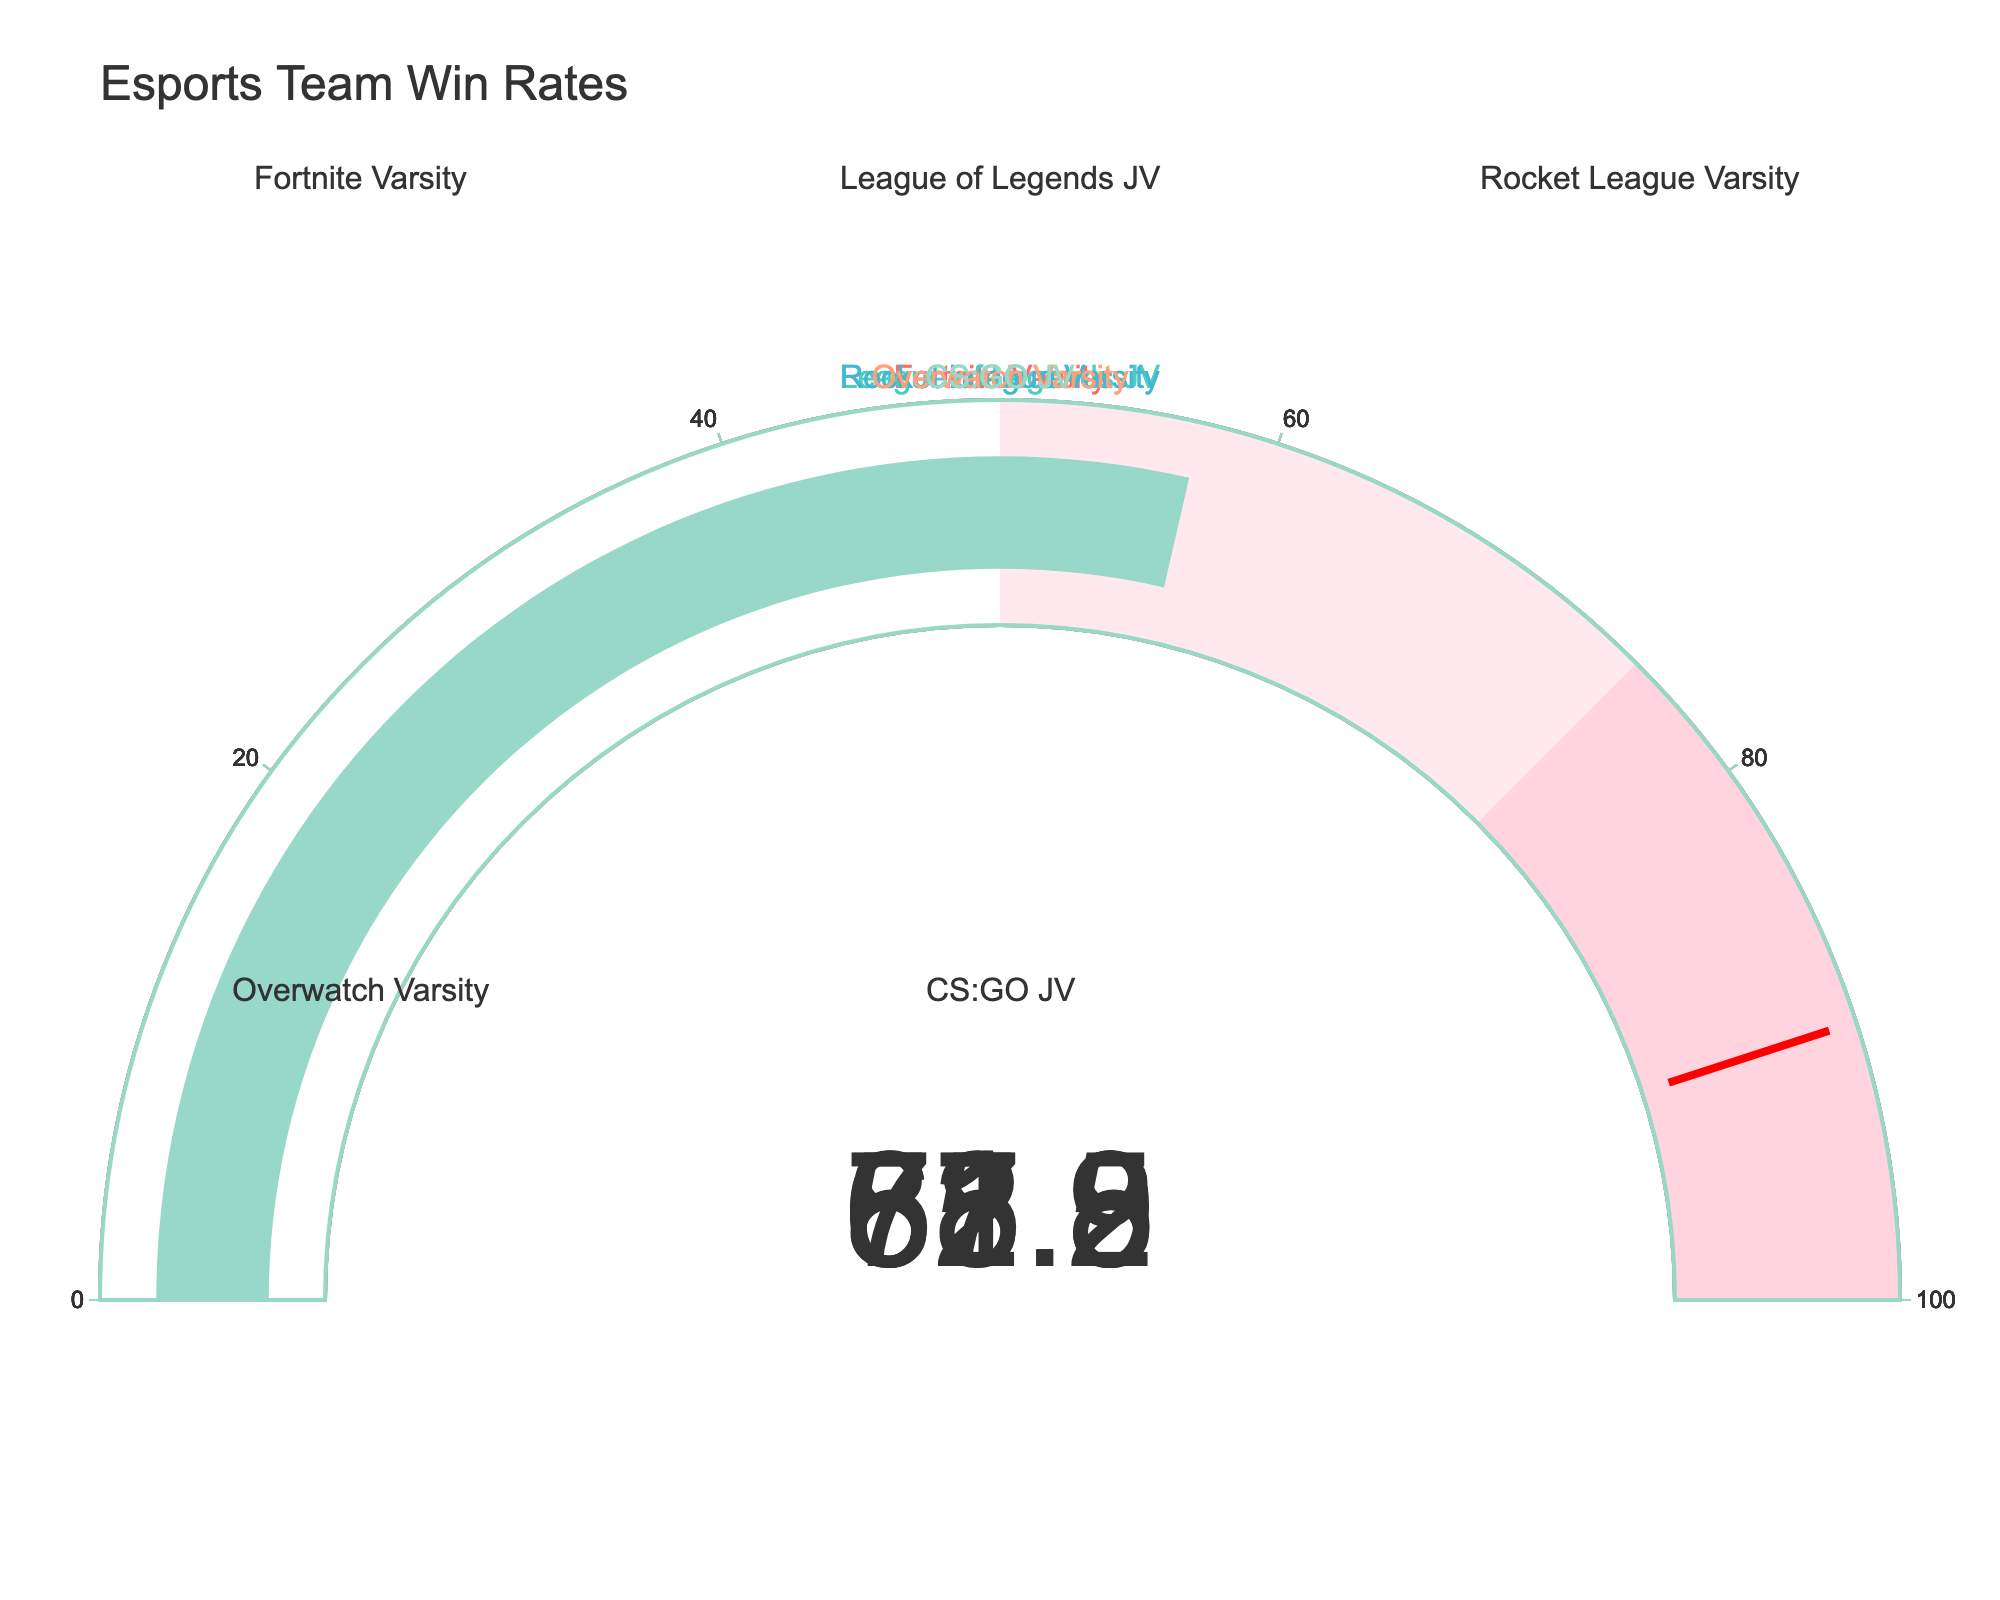How many teams are represented in the win rate figure? Count the number of gauges shown in the figure. There are a total of five teams represented in the win rate figure.
Answer: Five Which team has the highest win rate? Compare the win rate values displayed on the gauges and identify the highest one. The Rocket League Varsity team has the highest win rate displayed at 85.3.
Answer: Rocket League Varsity What is the average win rate of all teams? Sum all the win rates and divide by the number of teams. The win rates are 72.5, 61.8, 85.3, 68.9, and 57.2. Their sum is 345.7, and there are five teams. Thus, the average win rate is 345.7 / 5 = 69.14.
Answer: 69.14 How many teams have a win rate above 70? Check each gauge for win rates above 70. The teams are Fortnite Varsity (72.5) and Rocket League Varsity (85.3). There are two teams.
Answer: Two Which team has the lowest win rate? Compare all the win rates and identify the lowest one. The CS:GO JV team has the lowest win rate displayed at 57.2.
Answer: CS:GO JV What is the difference in win rate between the team with the highest win rate and the team with the lowest win rate? Subtract the lowest win rate from the highest win rate. The highest win rate is 85.3 (Rocket League Varsity), and the lowest win rate is 57.2 (CS:GO JV). The difference is 85.3 - 57.2 = 28.1.
Answer: 28.1 What is the win rate of the League of Legends JV team? Refer to the gauge displaying League of Legends JV win rate. The win rate is 61.8%.
Answer: 61.8% How many Varsity teams are there and what is their average win rate? Count the number of teams labeled 'Varsity' and calculate their average win rate. The Varsity teams are Fortnite Varsity, Rocket League Varsity, and Overwatch Varsity. Their win rates are 72.5, 85.3, and 68.9, respectively. The sum is 226.7, and there are three teams, so their average win rate is 226.7 / 3 = 75.57.
Answer: 75.57 